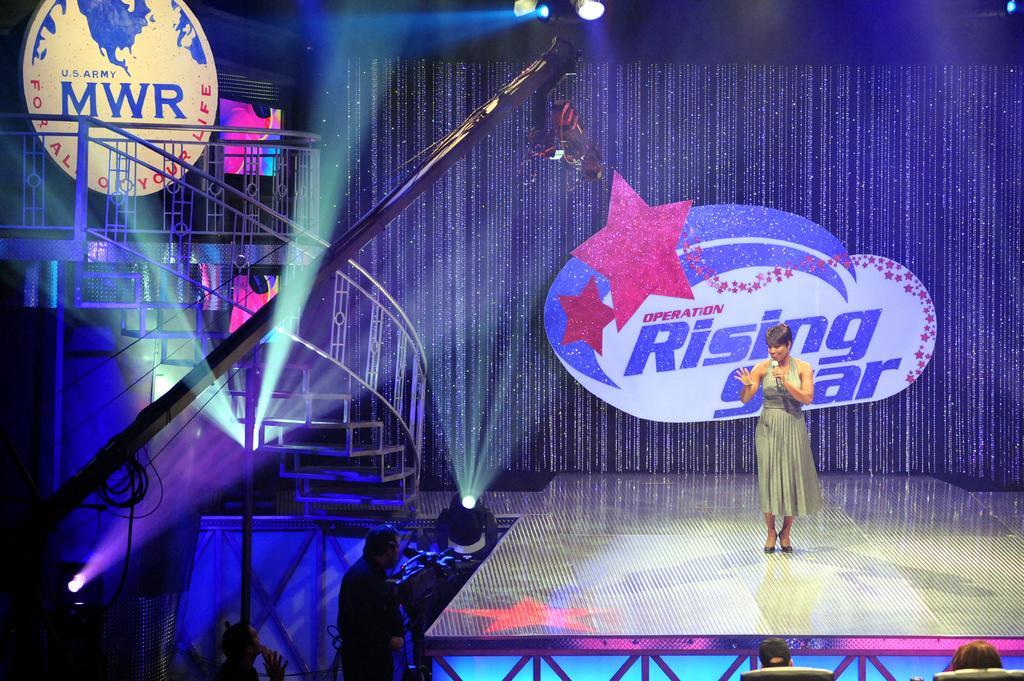Describe this image in one or two sentences. In this picture we can see a woman is standing on a stage and holding a microphone, on the left side there are stairs, we can see a board at the left top of the picture, we can see two persons at the bottom, there are lights at the top of the picture. 